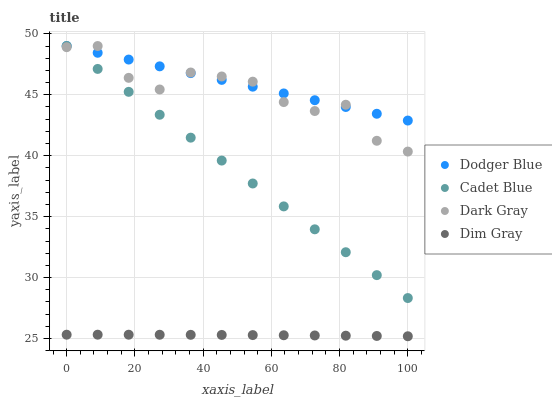Does Dim Gray have the minimum area under the curve?
Answer yes or no. Yes. Does Dodger Blue have the maximum area under the curve?
Answer yes or no. Yes. Does Cadet Blue have the minimum area under the curve?
Answer yes or no. No. Does Cadet Blue have the maximum area under the curve?
Answer yes or no. No. Is Dodger Blue the smoothest?
Answer yes or no. Yes. Is Dark Gray the roughest?
Answer yes or no. Yes. Is Dim Gray the smoothest?
Answer yes or no. No. Is Dim Gray the roughest?
Answer yes or no. No. Does Dim Gray have the lowest value?
Answer yes or no. Yes. Does Cadet Blue have the lowest value?
Answer yes or no. No. Does Dodger Blue have the highest value?
Answer yes or no. Yes. Does Dim Gray have the highest value?
Answer yes or no. No. Is Dim Gray less than Dodger Blue?
Answer yes or no. Yes. Is Dodger Blue greater than Dim Gray?
Answer yes or no. Yes. Does Cadet Blue intersect Dodger Blue?
Answer yes or no. Yes. Is Cadet Blue less than Dodger Blue?
Answer yes or no. No. Is Cadet Blue greater than Dodger Blue?
Answer yes or no. No. Does Dim Gray intersect Dodger Blue?
Answer yes or no. No. 